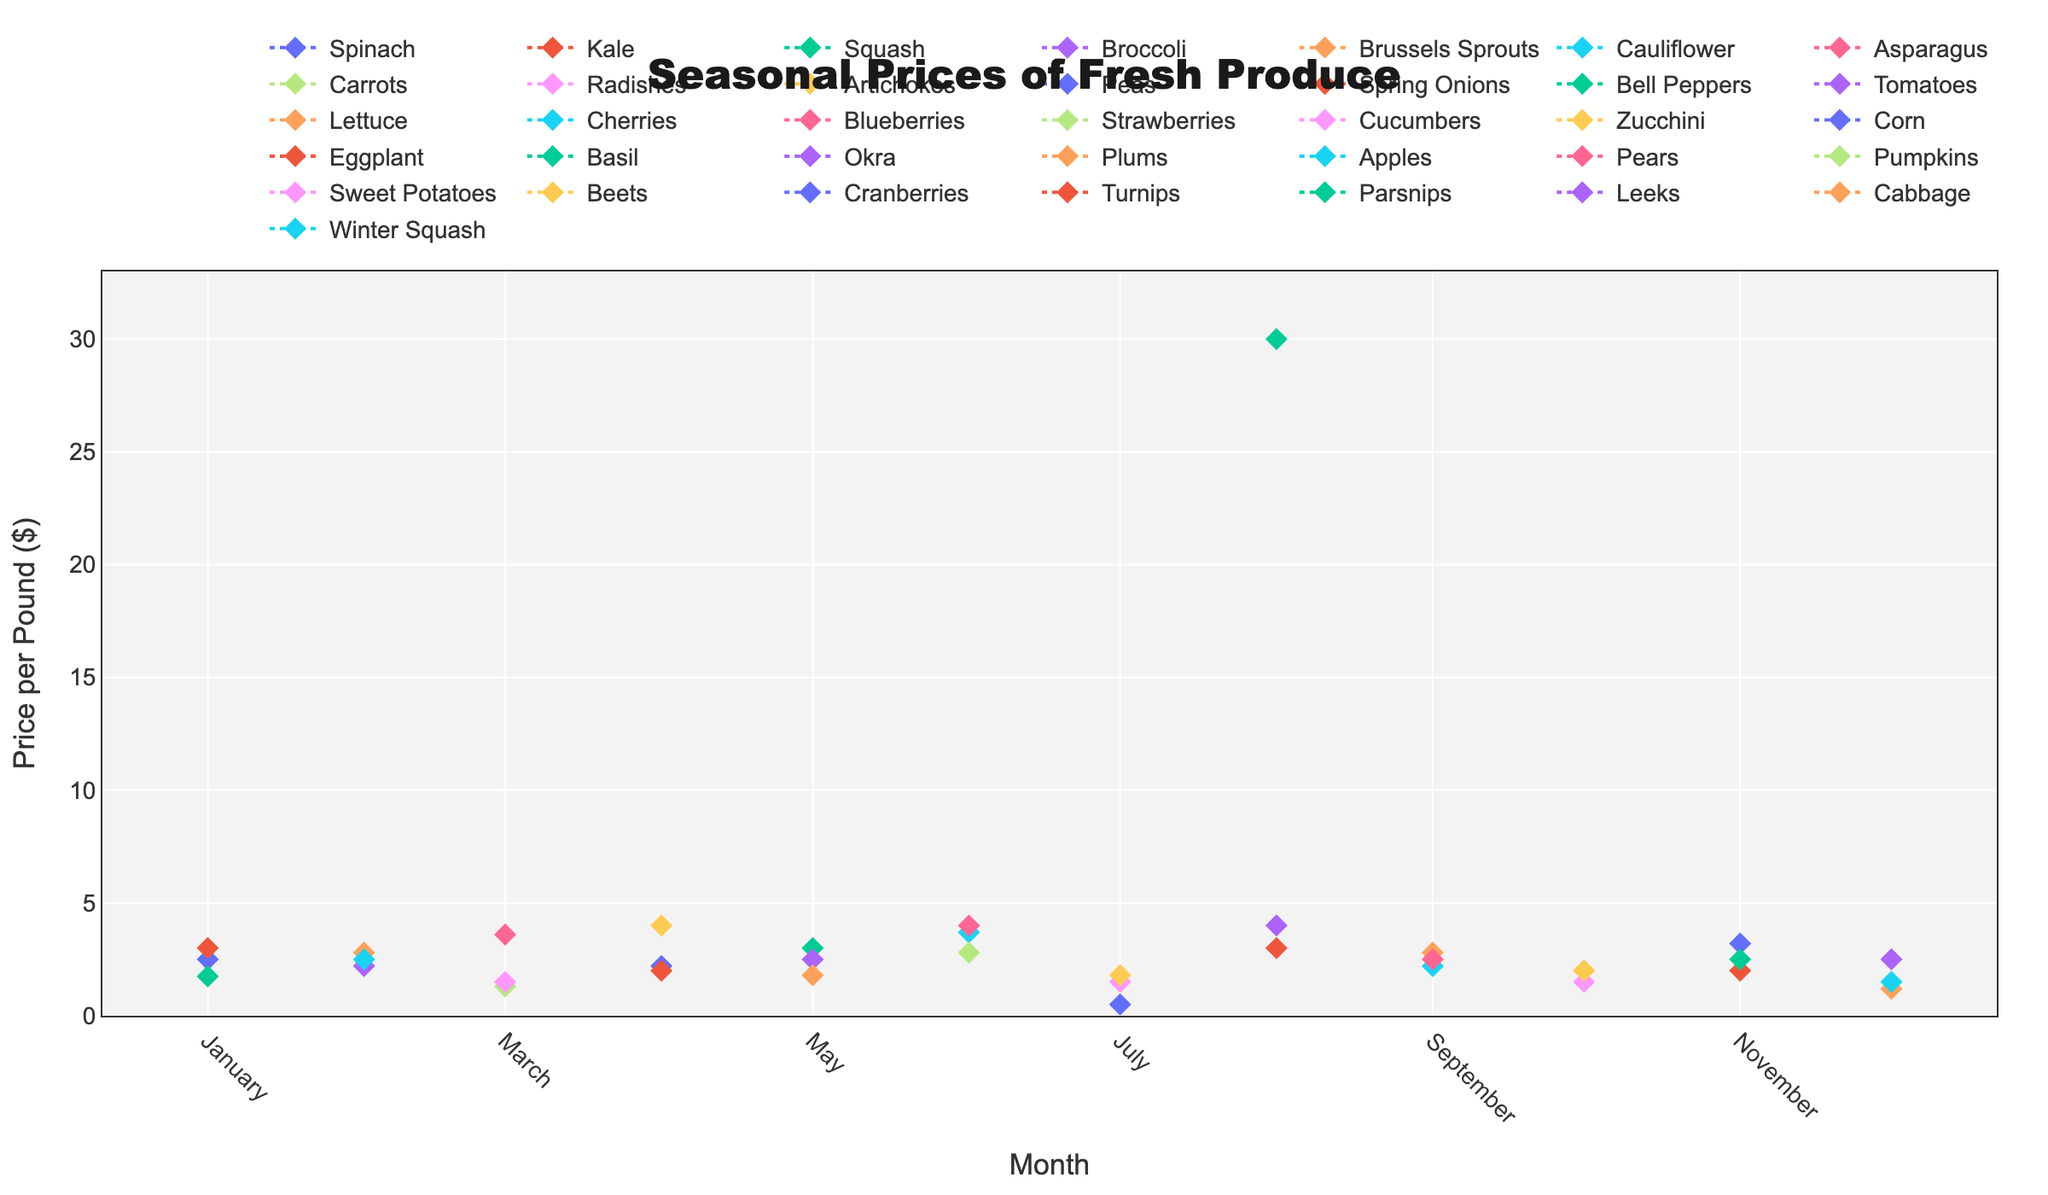Which month has the highest price for Asparagus? Look for the line representing Asparagus and identify the peak point. The price for Asparagus is highest in March.
Answer: March What is the price range of Bell Peppers throughout the year? Identify the data points for Bell Peppers and calculate the difference between the highest and lowest prices. Bell Peppers are only shown in May, with a price of $3.00.
Answer: $3.00 How does the price of Blueberries change from June to July? Look at the data points for Blueberries in June and July and note if there is an increase, decrease, or no change. Blueberries are only documented in June at $4.00.
Answer: No data for July Which month shows the highest availability of different produce items? Count the number of unique items with high availability in each month and identify the month with the highest count. Multiple months have a large number of items available: March, April, May, June, July, August, September, October, and November.
Answer: Multiple months What is the average price of produce in January? Add the prices of Spinach, Kale, and Squash in January, then divide by the number of items. (2.50 + 3.00 + 1.75) / 3 = 2.42.
Answer: $2.42 Between which two successive months does the price of a specific item change the most? Compare the month-to-month price changes for each item and find the largest difference. Basil's price in August ($30.00) is significantly higher than any other produce price this year. This is likely a key change, but data per month are mostly January-December without successive comparisons.
Answer: Unclear During which month are Strawberries available, and what is their price per pound? Identify the month when Strawberries are listed and note the associated price. Strawberries are available in June at $2.80 per pound.
Answer: June, $2.80 Is there any produce available in January priced below $2 per pound? Look at the prices of Spinach, Kale, and Squash in January and see if any are less than $2. Spinach is $2.50, Kale is $3.00, and Squash is $1.75.
Answer: Squash How does the availability of produce in February compare to April? Count and compare the number of produce items available in high quantity in both February and April. February has three high availability items, while April has three as well.
Answer: Equal Which produce has the highest price per pound in any month, and what is that price? Scan through the data points for all items and note the highest price. Basil in August is priced at $30.00 per pound.
Answer: Basil, $30.00 